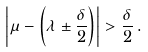Convert formula to latex. <formula><loc_0><loc_0><loc_500><loc_500>\left | \mu - \left ( \lambda \pm \frac { \delta } { 2 } \right ) \right | > \frac { \delta } { 2 } \, .</formula> 